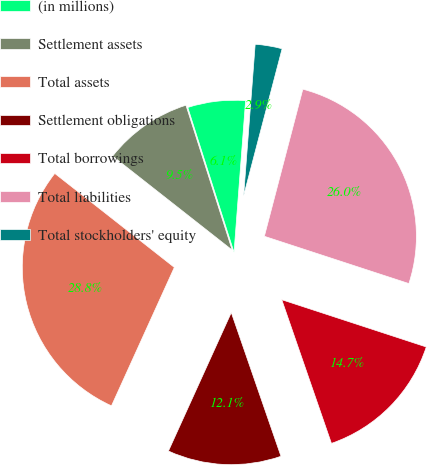Convert chart. <chart><loc_0><loc_0><loc_500><loc_500><pie_chart><fcel>(in millions)<fcel>Settlement assets<fcel>Total assets<fcel>Settlement obligations<fcel>Total borrowings<fcel>Total liabilities<fcel>Total stockholders' equity<nl><fcel>6.13%<fcel>9.48%<fcel>28.82%<fcel>12.08%<fcel>14.67%<fcel>25.96%<fcel>2.86%<nl></chart> 